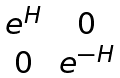Convert formula to latex. <formula><loc_0><loc_0><loc_500><loc_500>\begin{matrix} e ^ { H } & 0 \\ 0 & e ^ { - H } \\ \end{matrix}</formula> 